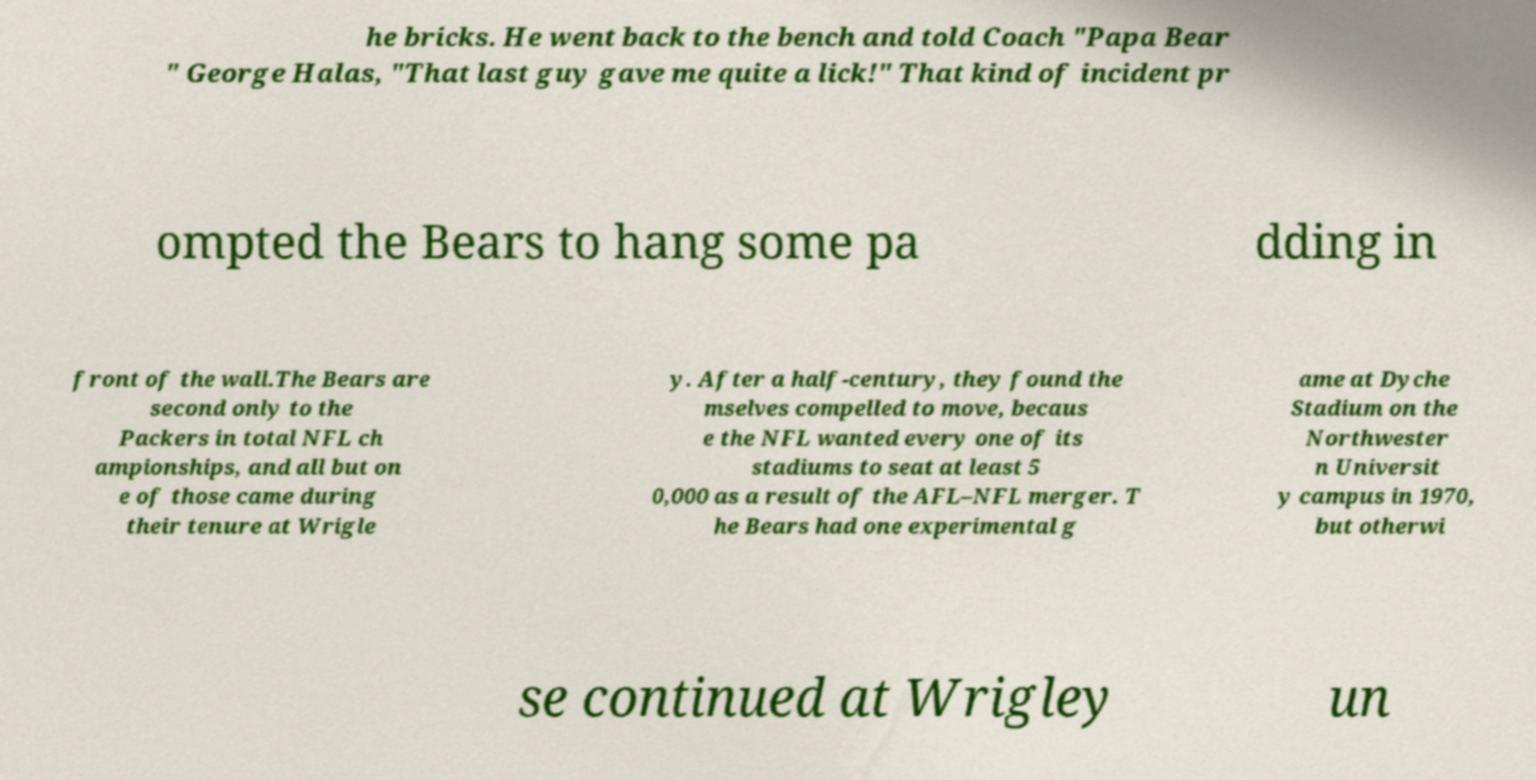There's text embedded in this image that I need extracted. Can you transcribe it verbatim? he bricks. He went back to the bench and told Coach "Papa Bear " George Halas, "That last guy gave me quite a lick!" That kind of incident pr ompted the Bears to hang some pa dding in front of the wall.The Bears are second only to the Packers in total NFL ch ampionships, and all but on e of those came during their tenure at Wrigle y. After a half-century, they found the mselves compelled to move, becaus e the NFL wanted every one of its stadiums to seat at least 5 0,000 as a result of the AFL–NFL merger. T he Bears had one experimental g ame at Dyche Stadium on the Northwester n Universit y campus in 1970, but otherwi se continued at Wrigley un 